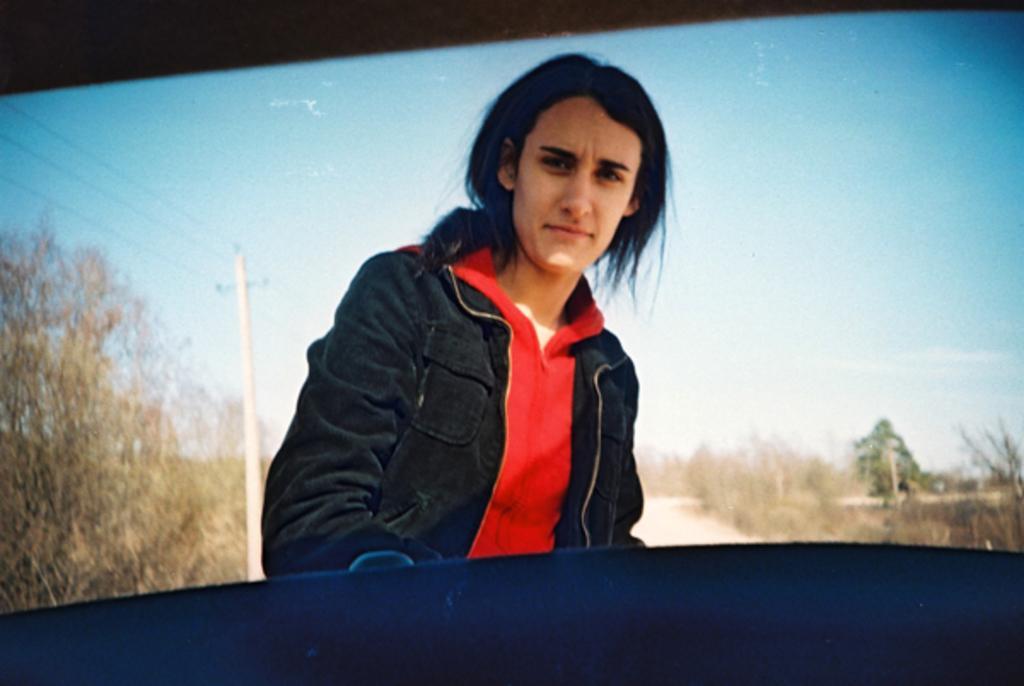Can you describe this image briefly? In the picture we can see a person wearing red color T-shirt, jacket standing and posing for a photograph and in the background of the picture there is road, there are some trees on left and right side of the picture and we can see an electric pole which is on left side of the picture and top of the picture there is clear sky. 